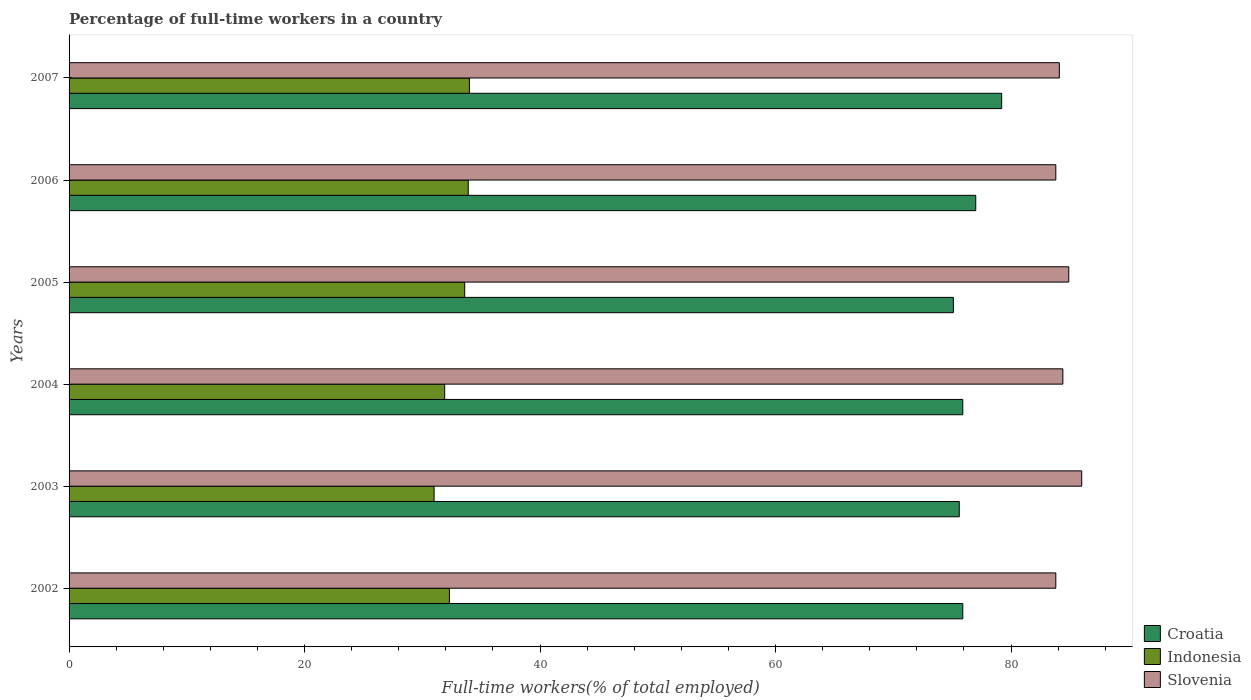How many different coloured bars are there?
Provide a succinct answer. 3. How many groups of bars are there?
Provide a succinct answer. 6. How many bars are there on the 4th tick from the top?
Give a very brief answer. 3. In how many cases, is the number of bars for a given year not equal to the number of legend labels?
Provide a short and direct response. 0. What is the percentage of full-time workers in Croatia in 2004?
Make the answer very short. 75.9. Across all years, what is the maximum percentage of full-time workers in Slovenia?
Provide a short and direct response. 86. In which year was the percentage of full-time workers in Indonesia maximum?
Offer a very short reply. 2007. In which year was the percentage of full-time workers in Croatia minimum?
Make the answer very short. 2005. What is the total percentage of full-time workers in Croatia in the graph?
Provide a succinct answer. 458.7. What is the difference between the percentage of full-time workers in Croatia in 2005 and the percentage of full-time workers in Slovenia in 2007?
Keep it short and to the point. -9. What is the average percentage of full-time workers in Slovenia per year?
Your response must be concise. 84.5. In the year 2006, what is the difference between the percentage of full-time workers in Croatia and percentage of full-time workers in Indonesia?
Provide a succinct answer. 43.1. What is the ratio of the percentage of full-time workers in Indonesia in 2005 to that in 2007?
Make the answer very short. 0.99. Is the percentage of full-time workers in Slovenia in 2002 less than that in 2005?
Keep it short and to the point. Yes. Is the difference between the percentage of full-time workers in Croatia in 2004 and 2007 greater than the difference between the percentage of full-time workers in Indonesia in 2004 and 2007?
Your answer should be compact. No. What is the difference between the highest and the second highest percentage of full-time workers in Slovenia?
Your answer should be compact. 1.1. What is the difference between the highest and the lowest percentage of full-time workers in Slovenia?
Keep it short and to the point. 2.2. Is the sum of the percentage of full-time workers in Slovenia in 2002 and 2005 greater than the maximum percentage of full-time workers in Croatia across all years?
Offer a terse response. Yes. What does the 3rd bar from the top in 2007 represents?
Keep it short and to the point. Croatia. Is it the case that in every year, the sum of the percentage of full-time workers in Slovenia and percentage of full-time workers in Croatia is greater than the percentage of full-time workers in Indonesia?
Offer a very short reply. Yes. How many bars are there?
Your answer should be compact. 18. Are all the bars in the graph horizontal?
Offer a terse response. Yes. How many years are there in the graph?
Provide a succinct answer. 6. What is the difference between two consecutive major ticks on the X-axis?
Your answer should be very brief. 20. Are the values on the major ticks of X-axis written in scientific E-notation?
Ensure brevity in your answer.  No. Does the graph contain any zero values?
Your answer should be very brief. No. Where does the legend appear in the graph?
Offer a terse response. Bottom right. What is the title of the graph?
Your answer should be compact. Percentage of full-time workers in a country. Does "Tanzania" appear as one of the legend labels in the graph?
Offer a very short reply. No. What is the label or title of the X-axis?
Offer a very short reply. Full-time workers(% of total employed). What is the Full-time workers(% of total employed) in Croatia in 2002?
Give a very brief answer. 75.9. What is the Full-time workers(% of total employed) in Indonesia in 2002?
Ensure brevity in your answer.  32.3. What is the Full-time workers(% of total employed) of Slovenia in 2002?
Offer a very short reply. 83.8. What is the Full-time workers(% of total employed) of Croatia in 2003?
Your answer should be very brief. 75.6. What is the Full-time workers(% of total employed) of Slovenia in 2003?
Offer a very short reply. 86. What is the Full-time workers(% of total employed) in Croatia in 2004?
Keep it short and to the point. 75.9. What is the Full-time workers(% of total employed) of Indonesia in 2004?
Provide a succinct answer. 31.9. What is the Full-time workers(% of total employed) in Slovenia in 2004?
Provide a short and direct response. 84.4. What is the Full-time workers(% of total employed) in Croatia in 2005?
Keep it short and to the point. 75.1. What is the Full-time workers(% of total employed) of Indonesia in 2005?
Your answer should be compact. 33.6. What is the Full-time workers(% of total employed) in Slovenia in 2005?
Keep it short and to the point. 84.9. What is the Full-time workers(% of total employed) of Indonesia in 2006?
Keep it short and to the point. 33.9. What is the Full-time workers(% of total employed) in Slovenia in 2006?
Give a very brief answer. 83.8. What is the Full-time workers(% of total employed) of Croatia in 2007?
Your response must be concise. 79.2. What is the Full-time workers(% of total employed) of Indonesia in 2007?
Make the answer very short. 34. What is the Full-time workers(% of total employed) in Slovenia in 2007?
Give a very brief answer. 84.1. Across all years, what is the maximum Full-time workers(% of total employed) of Croatia?
Keep it short and to the point. 79.2. Across all years, what is the minimum Full-time workers(% of total employed) of Croatia?
Provide a succinct answer. 75.1. Across all years, what is the minimum Full-time workers(% of total employed) in Indonesia?
Provide a short and direct response. 31. Across all years, what is the minimum Full-time workers(% of total employed) in Slovenia?
Provide a succinct answer. 83.8. What is the total Full-time workers(% of total employed) in Croatia in the graph?
Your answer should be compact. 458.7. What is the total Full-time workers(% of total employed) in Indonesia in the graph?
Your response must be concise. 196.7. What is the total Full-time workers(% of total employed) of Slovenia in the graph?
Ensure brevity in your answer.  507. What is the difference between the Full-time workers(% of total employed) of Croatia in 2002 and that in 2003?
Make the answer very short. 0.3. What is the difference between the Full-time workers(% of total employed) of Indonesia in 2002 and that in 2003?
Your answer should be very brief. 1.3. What is the difference between the Full-time workers(% of total employed) in Croatia in 2002 and that in 2004?
Keep it short and to the point. 0. What is the difference between the Full-time workers(% of total employed) in Croatia in 2002 and that in 2005?
Give a very brief answer. 0.8. What is the difference between the Full-time workers(% of total employed) of Indonesia in 2002 and that in 2005?
Keep it short and to the point. -1.3. What is the difference between the Full-time workers(% of total employed) of Slovenia in 2002 and that in 2006?
Offer a terse response. 0. What is the difference between the Full-time workers(% of total employed) in Croatia in 2002 and that in 2007?
Your response must be concise. -3.3. What is the difference between the Full-time workers(% of total employed) of Slovenia in 2002 and that in 2007?
Ensure brevity in your answer.  -0.3. What is the difference between the Full-time workers(% of total employed) in Croatia in 2003 and that in 2004?
Provide a short and direct response. -0.3. What is the difference between the Full-time workers(% of total employed) of Slovenia in 2003 and that in 2004?
Give a very brief answer. 1.6. What is the difference between the Full-time workers(% of total employed) in Indonesia in 2003 and that in 2005?
Your answer should be very brief. -2.6. What is the difference between the Full-time workers(% of total employed) of Slovenia in 2003 and that in 2005?
Provide a succinct answer. 1.1. What is the difference between the Full-time workers(% of total employed) of Slovenia in 2003 and that in 2006?
Keep it short and to the point. 2.2. What is the difference between the Full-time workers(% of total employed) in Slovenia in 2003 and that in 2007?
Give a very brief answer. 1.9. What is the difference between the Full-time workers(% of total employed) in Croatia in 2004 and that in 2005?
Offer a very short reply. 0.8. What is the difference between the Full-time workers(% of total employed) in Croatia in 2004 and that in 2006?
Give a very brief answer. -1.1. What is the difference between the Full-time workers(% of total employed) in Indonesia in 2004 and that in 2006?
Provide a succinct answer. -2. What is the difference between the Full-time workers(% of total employed) of Croatia in 2004 and that in 2007?
Your response must be concise. -3.3. What is the difference between the Full-time workers(% of total employed) in Slovenia in 2004 and that in 2007?
Offer a terse response. 0.3. What is the difference between the Full-time workers(% of total employed) of Croatia in 2005 and that in 2006?
Your answer should be compact. -1.9. What is the difference between the Full-time workers(% of total employed) of Indonesia in 2005 and that in 2006?
Make the answer very short. -0.3. What is the difference between the Full-time workers(% of total employed) of Slovenia in 2005 and that in 2006?
Give a very brief answer. 1.1. What is the difference between the Full-time workers(% of total employed) of Croatia in 2006 and that in 2007?
Your answer should be very brief. -2.2. What is the difference between the Full-time workers(% of total employed) of Indonesia in 2006 and that in 2007?
Ensure brevity in your answer.  -0.1. What is the difference between the Full-time workers(% of total employed) of Slovenia in 2006 and that in 2007?
Keep it short and to the point. -0.3. What is the difference between the Full-time workers(% of total employed) in Croatia in 2002 and the Full-time workers(% of total employed) in Indonesia in 2003?
Provide a succinct answer. 44.9. What is the difference between the Full-time workers(% of total employed) of Croatia in 2002 and the Full-time workers(% of total employed) of Slovenia in 2003?
Offer a terse response. -10.1. What is the difference between the Full-time workers(% of total employed) of Indonesia in 2002 and the Full-time workers(% of total employed) of Slovenia in 2003?
Your answer should be compact. -53.7. What is the difference between the Full-time workers(% of total employed) in Croatia in 2002 and the Full-time workers(% of total employed) in Indonesia in 2004?
Offer a very short reply. 44. What is the difference between the Full-time workers(% of total employed) of Indonesia in 2002 and the Full-time workers(% of total employed) of Slovenia in 2004?
Provide a short and direct response. -52.1. What is the difference between the Full-time workers(% of total employed) of Croatia in 2002 and the Full-time workers(% of total employed) of Indonesia in 2005?
Ensure brevity in your answer.  42.3. What is the difference between the Full-time workers(% of total employed) in Indonesia in 2002 and the Full-time workers(% of total employed) in Slovenia in 2005?
Make the answer very short. -52.6. What is the difference between the Full-time workers(% of total employed) in Croatia in 2002 and the Full-time workers(% of total employed) in Indonesia in 2006?
Provide a succinct answer. 42. What is the difference between the Full-time workers(% of total employed) in Croatia in 2002 and the Full-time workers(% of total employed) in Slovenia in 2006?
Ensure brevity in your answer.  -7.9. What is the difference between the Full-time workers(% of total employed) in Indonesia in 2002 and the Full-time workers(% of total employed) in Slovenia in 2006?
Provide a succinct answer. -51.5. What is the difference between the Full-time workers(% of total employed) of Croatia in 2002 and the Full-time workers(% of total employed) of Indonesia in 2007?
Your answer should be compact. 41.9. What is the difference between the Full-time workers(% of total employed) in Croatia in 2002 and the Full-time workers(% of total employed) in Slovenia in 2007?
Your answer should be very brief. -8.2. What is the difference between the Full-time workers(% of total employed) of Indonesia in 2002 and the Full-time workers(% of total employed) of Slovenia in 2007?
Ensure brevity in your answer.  -51.8. What is the difference between the Full-time workers(% of total employed) of Croatia in 2003 and the Full-time workers(% of total employed) of Indonesia in 2004?
Your answer should be very brief. 43.7. What is the difference between the Full-time workers(% of total employed) in Croatia in 2003 and the Full-time workers(% of total employed) in Slovenia in 2004?
Your response must be concise. -8.8. What is the difference between the Full-time workers(% of total employed) of Indonesia in 2003 and the Full-time workers(% of total employed) of Slovenia in 2004?
Offer a terse response. -53.4. What is the difference between the Full-time workers(% of total employed) of Croatia in 2003 and the Full-time workers(% of total employed) of Indonesia in 2005?
Give a very brief answer. 42. What is the difference between the Full-time workers(% of total employed) in Croatia in 2003 and the Full-time workers(% of total employed) in Slovenia in 2005?
Offer a very short reply. -9.3. What is the difference between the Full-time workers(% of total employed) of Indonesia in 2003 and the Full-time workers(% of total employed) of Slovenia in 2005?
Your response must be concise. -53.9. What is the difference between the Full-time workers(% of total employed) in Croatia in 2003 and the Full-time workers(% of total employed) in Indonesia in 2006?
Offer a very short reply. 41.7. What is the difference between the Full-time workers(% of total employed) of Indonesia in 2003 and the Full-time workers(% of total employed) of Slovenia in 2006?
Offer a terse response. -52.8. What is the difference between the Full-time workers(% of total employed) of Croatia in 2003 and the Full-time workers(% of total employed) of Indonesia in 2007?
Ensure brevity in your answer.  41.6. What is the difference between the Full-time workers(% of total employed) in Indonesia in 2003 and the Full-time workers(% of total employed) in Slovenia in 2007?
Your response must be concise. -53.1. What is the difference between the Full-time workers(% of total employed) of Croatia in 2004 and the Full-time workers(% of total employed) of Indonesia in 2005?
Offer a terse response. 42.3. What is the difference between the Full-time workers(% of total employed) in Croatia in 2004 and the Full-time workers(% of total employed) in Slovenia in 2005?
Provide a succinct answer. -9. What is the difference between the Full-time workers(% of total employed) of Indonesia in 2004 and the Full-time workers(% of total employed) of Slovenia in 2005?
Keep it short and to the point. -53. What is the difference between the Full-time workers(% of total employed) in Croatia in 2004 and the Full-time workers(% of total employed) in Slovenia in 2006?
Provide a succinct answer. -7.9. What is the difference between the Full-time workers(% of total employed) of Indonesia in 2004 and the Full-time workers(% of total employed) of Slovenia in 2006?
Provide a succinct answer. -51.9. What is the difference between the Full-time workers(% of total employed) in Croatia in 2004 and the Full-time workers(% of total employed) in Indonesia in 2007?
Offer a very short reply. 41.9. What is the difference between the Full-time workers(% of total employed) of Indonesia in 2004 and the Full-time workers(% of total employed) of Slovenia in 2007?
Your response must be concise. -52.2. What is the difference between the Full-time workers(% of total employed) of Croatia in 2005 and the Full-time workers(% of total employed) of Indonesia in 2006?
Provide a succinct answer. 41.2. What is the difference between the Full-time workers(% of total employed) in Croatia in 2005 and the Full-time workers(% of total employed) in Slovenia in 2006?
Provide a short and direct response. -8.7. What is the difference between the Full-time workers(% of total employed) in Indonesia in 2005 and the Full-time workers(% of total employed) in Slovenia in 2006?
Offer a very short reply. -50.2. What is the difference between the Full-time workers(% of total employed) in Croatia in 2005 and the Full-time workers(% of total employed) in Indonesia in 2007?
Provide a short and direct response. 41.1. What is the difference between the Full-time workers(% of total employed) of Croatia in 2005 and the Full-time workers(% of total employed) of Slovenia in 2007?
Offer a very short reply. -9. What is the difference between the Full-time workers(% of total employed) in Indonesia in 2005 and the Full-time workers(% of total employed) in Slovenia in 2007?
Provide a succinct answer. -50.5. What is the difference between the Full-time workers(% of total employed) in Indonesia in 2006 and the Full-time workers(% of total employed) in Slovenia in 2007?
Your answer should be very brief. -50.2. What is the average Full-time workers(% of total employed) in Croatia per year?
Make the answer very short. 76.45. What is the average Full-time workers(% of total employed) of Indonesia per year?
Make the answer very short. 32.78. What is the average Full-time workers(% of total employed) of Slovenia per year?
Offer a very short reply. 84.5. In the year 2002, what is the difference between the Full-time workers(% of total employed) of Croatia and Full-time workers(% of total employed) of Indonesia?
Provide a short and direct response. 43.6. In the year 2002, what is the difference between the Full-time workers(% of total employed) of Croatia and Full-time workers(% of total employed) of Slovenia?
Your response must be concise. -7.9. In the year 2002, what is the difference between the Full-time workers(% of total employed) in Indonesia and Full-time workers(% of total employed) in Slovenia?
Keep it short and to the point. -51.5. In the year 2003, what is the difference between the Full-time workers(% of total employed) in Croatia and Full-time workers(% of total employed) in Indonesia?
Your response must be concise. 44.6. In the year 2003, what is the difference between the Full-time workers(% of total employed) of Croatia and Full-time workers(% of total employed) of Slovenia?
Offer a terse response. -10.4. In the year 2003, what is the difference between the Full-time workers(% of total employed) of Indonesia and Full-time workers(% of total employed) of Slovenia?
Ensure brevity in your answer.  -55. In the year 2004, what is the difference between the Full-time workers(% of total employed) of Indonesia and Full-time workers(% of total employed) of Slovenia?
Your answer should be very brief. -52.5. In the year 2005, what is the difference between the Full-time workers(% of total employed) in Croatia and Full-time workers(% of total employed) in Indonesia?
Ensure brevity in your answer.  41.5. In the year 2005, what is the difference between the Full-time workers(% of total employed) of Croatia and Full-time workers(% of total employed) of Slovenia?
Your answer should be compact. -9.8. In the year 2005, what is the difference between the Full-time workers(% of total employed) in Indonesia and Full-time workers(% of total employed) in Slovenia?
Offer a very short reply. -51.3. In the year 2006, what is the difference between the Full-time workers(% of total employed) in Croatia and Full-time workers(% of total employed) in Indonesia?
Give a very brief answer. 43.1. In the year 2006, what is the difference between the Full-time workers(% of total employed) in Indonesia and Full-time workers(% of total employed) in Slovenia?
Offer a terse response. -49.9. In the year 2007, what is the difference between the Full-time workers(% of total employed) in Croatia and Full-time workers(% of total employed) in Indonesia?
Provide a succinct answer. 45.2. In the year 2007, what is the difference between the Full-time workers(% of total employed) in Croatia and Full-time workers(% of total employed) in Slovenia?
Your response must be concise. -4.9. In the year 2007, what is the difference between the Full-time workers(% of total employed) in Indonesia and Full-time workers(% of total employed) in Slovenia?
Your response must be concise. -50.1. What is the ratio of the Full-time workers(% of total employed) of Indonesia in 2002 to that in 2003?
Offer a terse response. 1.04. What is the ratio of the Full-time workers(% of total employed) in Slovenia in 2002 to that in 2003?
Keep it short and to the point. 0.97. What is the ratio of the Full-time workers(% of total employed) of Croatia in 2002 to that in 2004?
Offer a terse response. 1. What is the ratio of the Full-time workers(% of total employed) in Indonesia in 2002 to that in 2004?
Offer a very short reply. 1.01. What is the ratio of the Full-time workers(% of total employed) in Slovenia in 2002 to that in 2004?
Ensure brevity in your answer.  0.99. What is the ratio of the Full-time workers(% of total employed) in Croatia in 2002 to that in 2005?
Your answer should be compact. 1.01. What is the ratio of the Full-time workers(% of total employed) in Indonesia in 2002 to that in 2005?
Your response must be concise. 0.96. What is the ratio of the Full-time workers(% of total employed) of Croatia in 2002 to that in 2006?
Your answer should be compact. 0.99. What is the ratio of the Full-time workers(% of total employed) in Indonesia in 2002 to that in 2006?
Keep it short and to the point. 0.95. What is the ratio of the Full-time workers(% of total employed) of Croatia in 2002 to that in 2007?
Offer a terse response. 0.96. What is the ratio of the Full-time workers(% of total employed) in Croatia in 2003 to that in 2004?
Offer a terse response. 1. What is the ratio of the Full-time workers(% of total employed) of Indonesia in 2003 to that in 2004?
Offer a terse response. 0.97. What is the ratio of the Full-time workers(% of total employed) of Indonesia in 2003 to that in 2005?
Your answer should be very brief. 0.92. What is the ratio of the Full-time workers(% of total employed) in Slovenia in 2003 to that in 2005?
Provide a short and direct response. 1.01. What is the ratio of the Full-time workers(% of total employed) in Croatia in 2003 to that in 2006?
Give a very brief answer. 0.98. What is the ratio of the Full-time workers(% of total employed) in Indonesia in 2003 to that in 2006?
Ensure brevity in your answer.  0.91. What is the ratio of the Full-time workers(% of total employed) of Slovenia in 2003 to that in 2006?
Your answer should be compact. 1.03. What is the ratio of the Full-time workers(% of total employed) in Croatia in 2003 to that in 2007?
Offer a terse response. 0.95. What is the ratio of the Full-time workers(% of total employed) in Indonesia in 2003 to that in 2007?
Offer a very short reply. 0.91. What is the ratio of the Full-time workers(% of total employed) of Slovenia in 2003 to that in 2007?
Keep it short and to the point. 1.02. What is the ratio of the Full-time workers(% of total employed) in Croatia in 2004 to that in 2005?
Your response must be concise. 1.01. What is the ratio of the Full-time workers(% of total employed) in Indonesia in 2004 to that in 2005?
Provide a short and direct response. 0.95. What is the ratio of the Full-time workers(% of total employed) of Croatia in 2004 to that in 2006?
Your answer should be very brief. 0.99. What is the ratio of the Full-time workers(% of total employed) in Indonesia in 2004 to that in 2006?
Provide a succinct answer. 0.94. What is the ratio of the Full-time workers(% of total employed) in Slovenia in 2004 to that in 2006?
Ensure brevity in your answer.  1.01. What is the ratio of the Full-time workers(% of total employed) of Croatia in 2004 to that in 2007?
Give a very brief answer. 0.96. What is the ratio of the Full-time workers(% of total employed) of Indonesia in 2004 to that in 2007?
Your answer should be compact. 0.94. What is the ratio of the Full-time workers(% of total employed) of Croatia in 2005 to that in 2006?
Ensure brevity in your answer.  0.98. What is the ratio of the Full-time workers(% of total employed) of Slovenia in 2005 to that in 2006?
Provide a short and direct response. 1.01. What is the ratio of the Full-time workers(% of total employed) of Croatia in 2005 to that in 2007?
Your answer should be very brief. 0.95. What is the ratio of the Full-time workers(% of total employed) of Slovenia in 2005 to that in 2007?
Provide a succinct answer. 1.01. What is the ratio of the Full-time workers(% of total employed) of Croatia in 2006 to that in 2007?
Keep it short and to the point. 0.97. What is the ratio of the Full-time workers(% of total employed) in Slovenia in 2006 to that in 2007?
Make the answer very short. 1. What is the difference between the highest and the lowest Full-time workers(% of total employed) in Indonesia?
Your answer should be compact. 3. What is the difference between the highest and the lowest Full-time workers(% of total employed) of Slovenia?
Give a very brief answer. 2.2. 